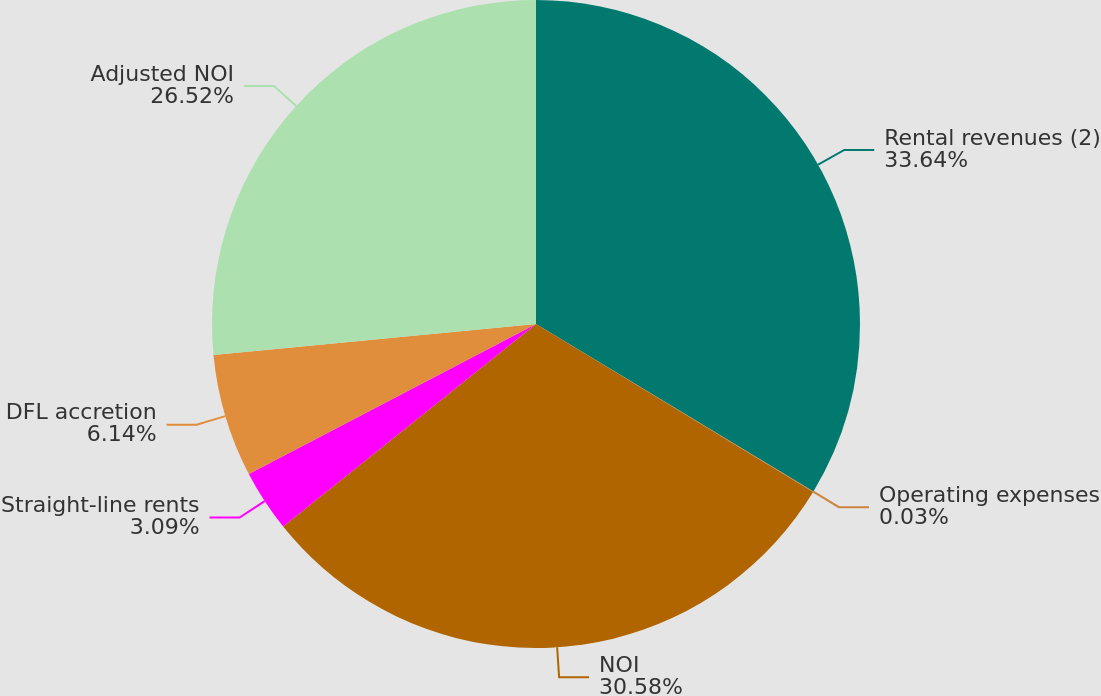<chart> <loc_0><loc_0><loc_500><loc_500><pie_chart><fcel>Rental revenues (2)<fcel>Operating expenses<fcel>NOI<fcel>Straight-line rents<fcel>DFL accretion<fcel>Adjusted NOI<nl><fcel>33.64%<fcel>0.03%<fcel>30.58%<fcel>3.09%<fcel>6.14%<fcel>26.52%<nl></chart> 